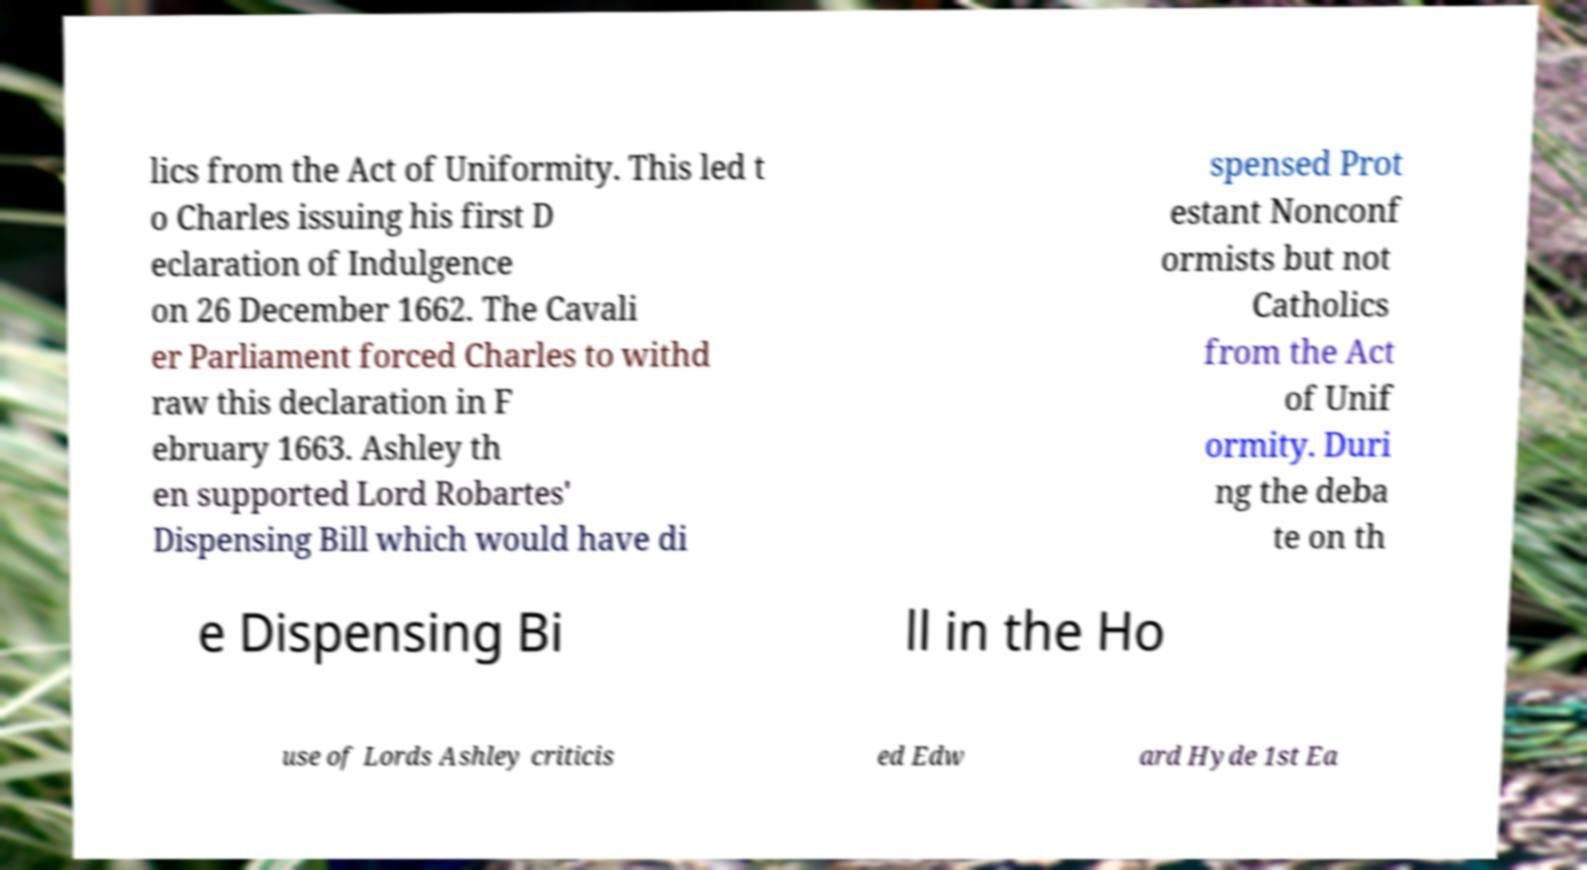For documentation purposes, I need the text within this image transcribed. Could you provide that? lics from the Act of Uniformity. This led t o Charles issuing his first D eclaration of Indulgence on 26 December 1662. The Cavali er Parliament forced Charles to withd raw this declaration in F ebruary 1663. Ashley th en supported Lord Robartes' Dispensing Bill which would have di spensed Prot estant Nonconf ormists but not Catholics from the Act of Unif ormity. Duri ng the deba te on th e Dispensing Bi ll in the Ho use of Lords Ashley criticis ed Edw ard Hyde 1st Ea 